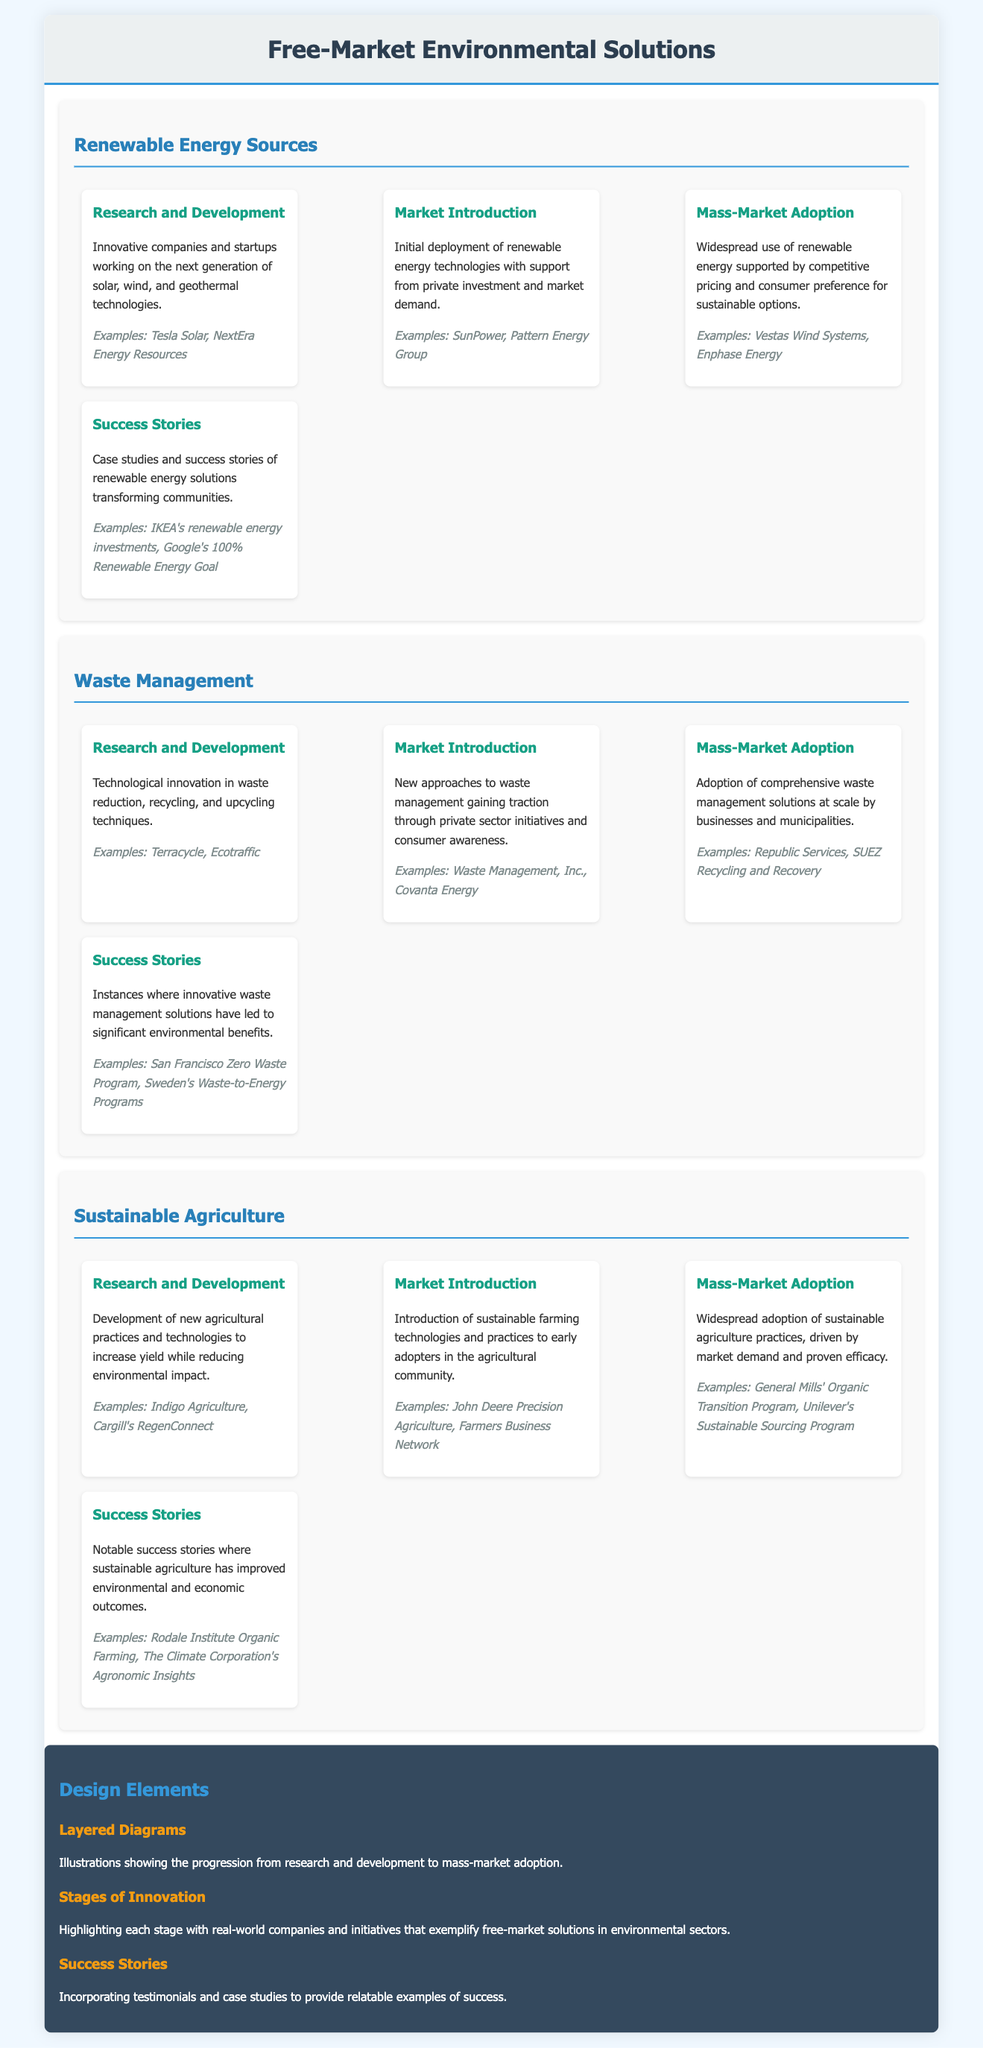What are the examples listed for renewable energy sources in the success stories section? The document mentions IKEA's renewable energy investments and Google's 100% Renewable Energy Goal as examples.
Answer: IKEA's renewable energy investments, Google's 100% Renewable Energy Goal What is the first stage in the Waste Management category? The document identifies "Research and Development" as the first stage in the Waste Management category.
Answer: Research and Development Which company is associated with market introduction in Sustainable Agriculture? The document states that John Deere Precision Agriculture is an example associated with market introduction in Sustainable Agriculture.
Answer: John Deere Precision Agriculture How many stages are listed under each category? Each category contains four stages, including Research and Development, Market Introduction, Mass-Market Adoption, and Success Stories.
Answer: Four stages What innovation is highlighted in the design elements? Layered Diagrams are mentioned as a design element that illustrates the progression from research and development to mass-market adoption.
Answer: Layered Diagrams What type of companies are included in the examples of mass-market adoption for renewable energy sources? The document lists Vestas Wind Systems and Enphase Energy as examples of companies in mass-market adoption for renewable energy sources.
Answer: Vestas Wind Systems, Enphase Energy What is a common theme in the success stories of the Waste Management category? The document highlights instances where innovative waste management solutions have led to significant environmental benefits as a common theme.
Answer: Significant environmental benefits Which company is noted for its sustainable practices in Market Introduction of Sustainable Agriculture? Farmers Business Network is noted as an example for the Market Introduction stage in Sustainable Agriculture.
Answer: Farmers Business Network How is consumer awareness related to waste management solutions? New approaches to waste management gaining traction through private sector initiatives and consumer awareness is highlighted in the document.
Answer: Private sector initiatives and consumer awareness 